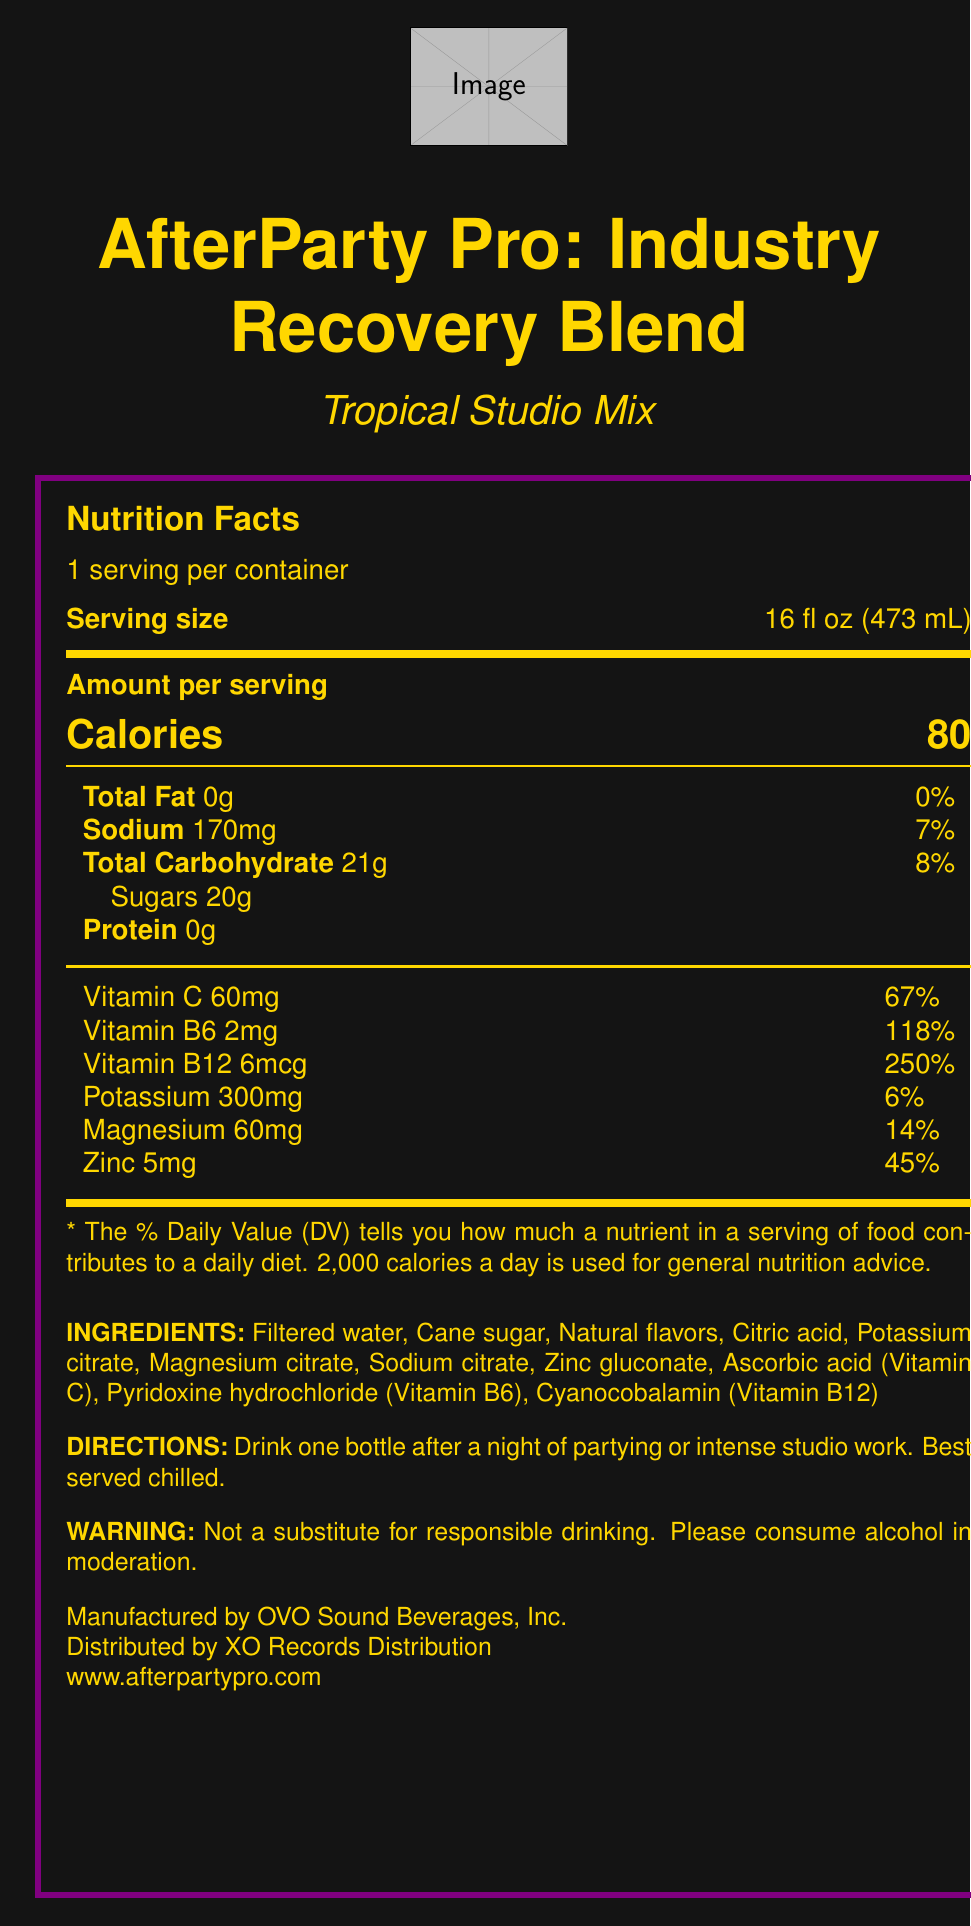what is the serving size of the AfterParty Pro drink? The serving size is explicitly stated in the document as 16 fl oz (473 mL).
Answer: 16 fl oz (473 mL) how many calories does one serving of AfterParty Pro contain? The document states that one serving contains 80 calories.
Answer: 80 what is the main benefit of consuming this drink after long studio sessions and late-night performances? The product description mentions that it is formulated to replenish essential electrolytes and vitamins for music industry professionals after long studio sessions and late-night performances.
Answer: It replenishes essential electrolytes and vitamins. how much sodium is there in one serving, and what percent of the daily value does it represent? The document provides these details directly, indicating that one serving contains 170mg of sodium, which is 7% of the daily value.
Answer: 170mg, 7% list the vitamins and their amounts present in one serving These details are found under the section listing the vitamins in one serving: 60mg of Vitamin C, 2mg of Vitamin B6, and 6mcg of Vitamin B12.
Answer: Vitamin C 60mg, Vitamin B6 2mg, Vitamin B12 6mcg which of the following ingredients is NOT included in the AfterParty Pro drink? A. Potassium citrate B. Cane sugar C. High fructose corn syrup D. Natural flavors The ingredients list does not mention high fructose corn syrup, making it the correct answer.
Answer: C. High fructose corn syrup what organization manufactures AfterParty Pro? The document states that OVO Sound Beverages, Inc. manufactures the drink.
Answer: OVO Sound Beverages, Inc. is AfterParty Pro drink recommended as a substitute for responsible drinking? The warning on the document specifies that it is not a substitute for responsible drinking.
Answer: No which key electrolyte is present in the highest amount in AfterParty Pro? A. Sodium B. Potassium C. Magnesium Potassium is listed as 300mg per serving, more than sodium (170mg) and magnesium (60mg).
Answer: B. Potassium what flavor is the AfterParty Pro drink? The document mentions that the flavor of the drink is "Tropical Studio Mix."
Answer: Tropical Studio Mix summarize the main idea of the AfterParty Pro drink's nutrition facts label and product description in two sentences. This summary encapsulates the key details, including the target audience, purpose, flavor, and main ingredients.
Answer: AfterParty Pro: Industry Recovery Blend is a drink designed for music industry professionals, containing essential electrolytes and vitamins to combat dehydration and recharge after demanding studio sessions and late-night performances. With a refreshing Tropical Studio Mix flavor, it includes key ingredients like potassium, magnesium, sodium, and vitamins B6, B12, and C. what is the exact website to find more information about AfterParty Pro? The document provides this specific URL for additional information.
Answer: www.afterpartypro.com how many grams of sugars are there in each serving of AfterParty Pro? The document clearly states there are 20 grams of sugars per serving.
Answer: 20g is there any information provided on the document about the expiration date of the AfterParty Pro drink? The document does not provide any details regarding the expiration date of the drink.
Answer: Not enough information 